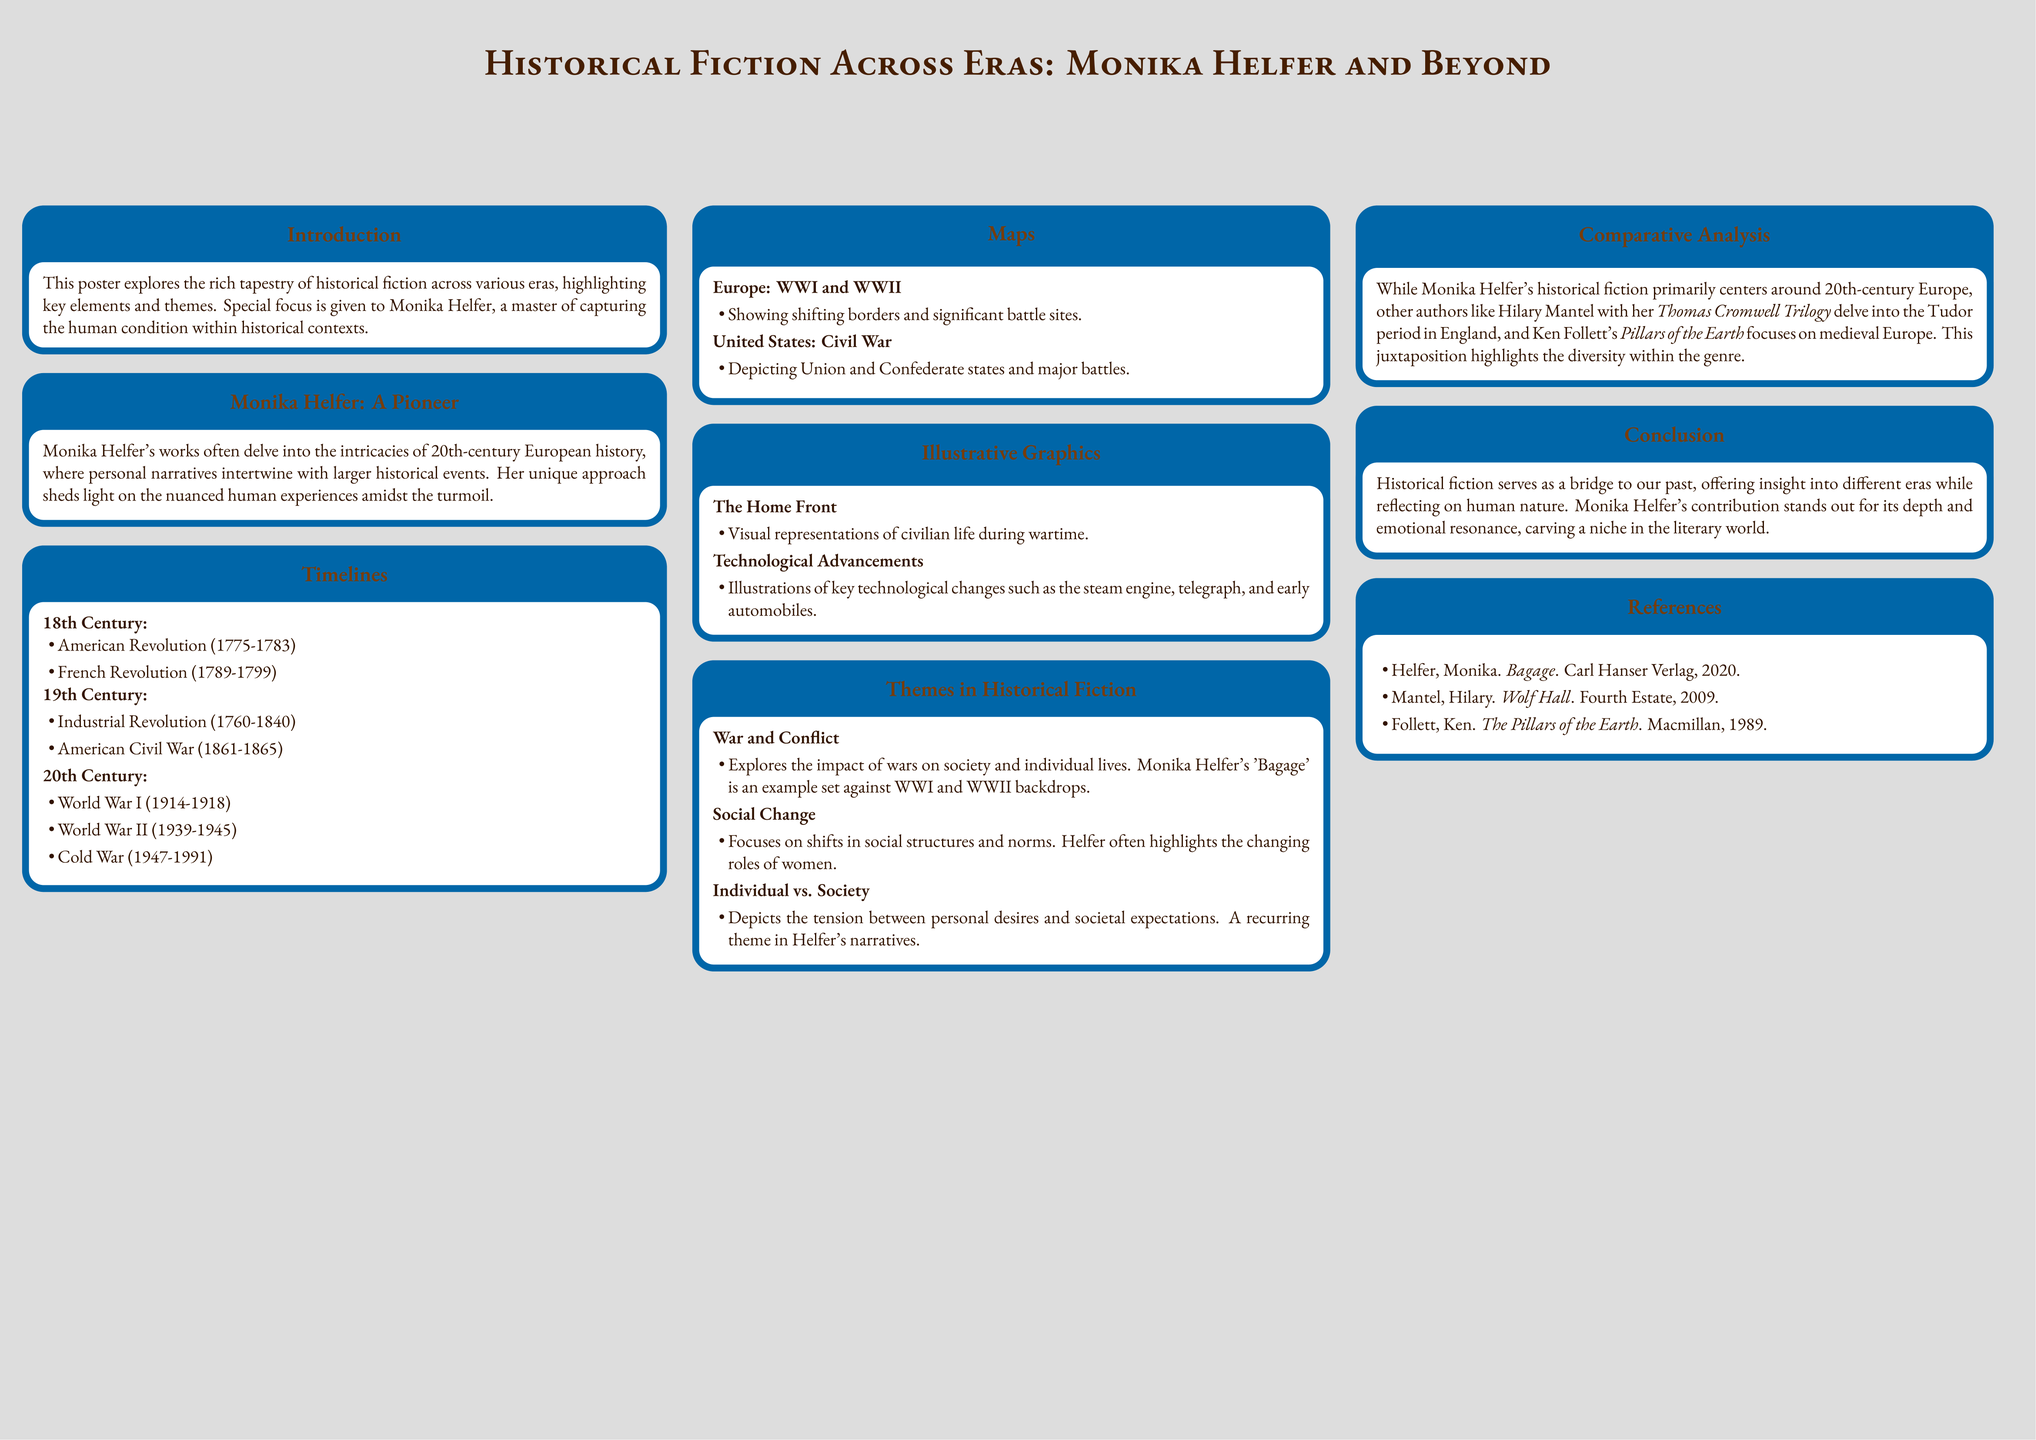What is the focus of Monika Helfer's works? The poster states that Monika Helfer's works delve into the intricacies of 20th-century European history.
Answer: 20th-century European history What major wars are mentioned in the timelines for the 20th century? The timeline includes World War I and World War II, as stated in the document.
Answer: World War I and World War II Which author is compared to Monika Helfer in the comparative analysis? The comparative analysis mentions Hilary Mantel as another author in historical fiction.
Answer: Hilary Mantel What significant event is associated with the 18th century in the timelines? The timeline lists the American Revolution as a major event in the 18th century.
Answer: American Revolution What theme does Helfer's 'Bagage' exemplify? The poster mentions that 'Bagage' explores the impact of wars on society and individual lives.
Answer: War and Conflict 